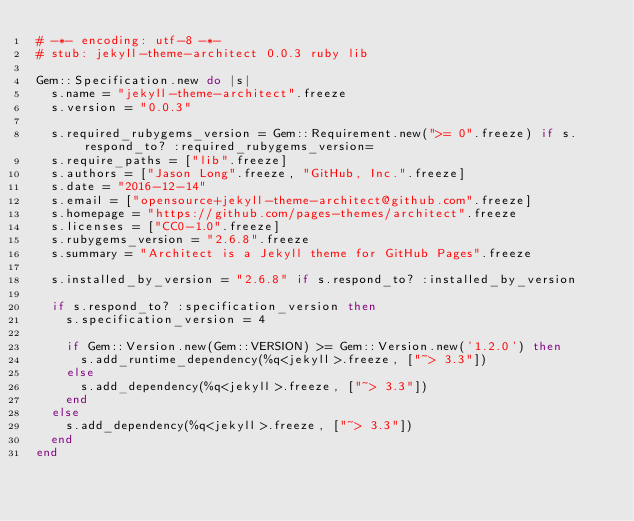<code> <loc_0><loc_0><loc_500><loc_500><_Ruby_># -*- encoding: utf-8 -*-
# stub: jekyll-theme-architect 0.0.3 ruby lib

Gem::Specification.new do |s|
  s.name = "jekyll-theme-architect".freeze
  s.version = "0.0.3"

  s.required_rubygems_version = Gem::Requirement.new(">= 0".freeze) if s.respond_to? :required_rubygems_version=
  s.require_paths = ["lib".freeze]
  s.authors = ["Jason Long".freeze, "GitHub, Inc.".freeze]
  s.date = "2016-12-14"
  s.email = ["opensource+jekyll-theme-architect@github.com".freeze]
  s.homepage = "https://github.com/pages-themes/architect".freeze
  s.licenses = ["CC0-1.0".freeze]
  s.rubygems_version = "2.6.8".freeze
  s.summary = "Architect is a Jekyll theme for GitHub Pages".freeze

  s.installed_by_version = "2.6.8" if s.respond_to? :installed_by_version

  if s.respond_to? :specification_version then
    s.specification_version = 4

    if Gem::Version.new(Gem::VERSION) >= Gem::Version.new('1.2.0') then
      s.add_runtime_dependency(%q<jekyll>.freeze, ["~> 3.3"])
    else
      s.add_dependency(%q<jekyll>.freeze, ["~> 3.3"])
    end
  else
    s.add_dependency(%q<jekyll>.freeze, ["~> 3.3"])
  end
end
</code> 